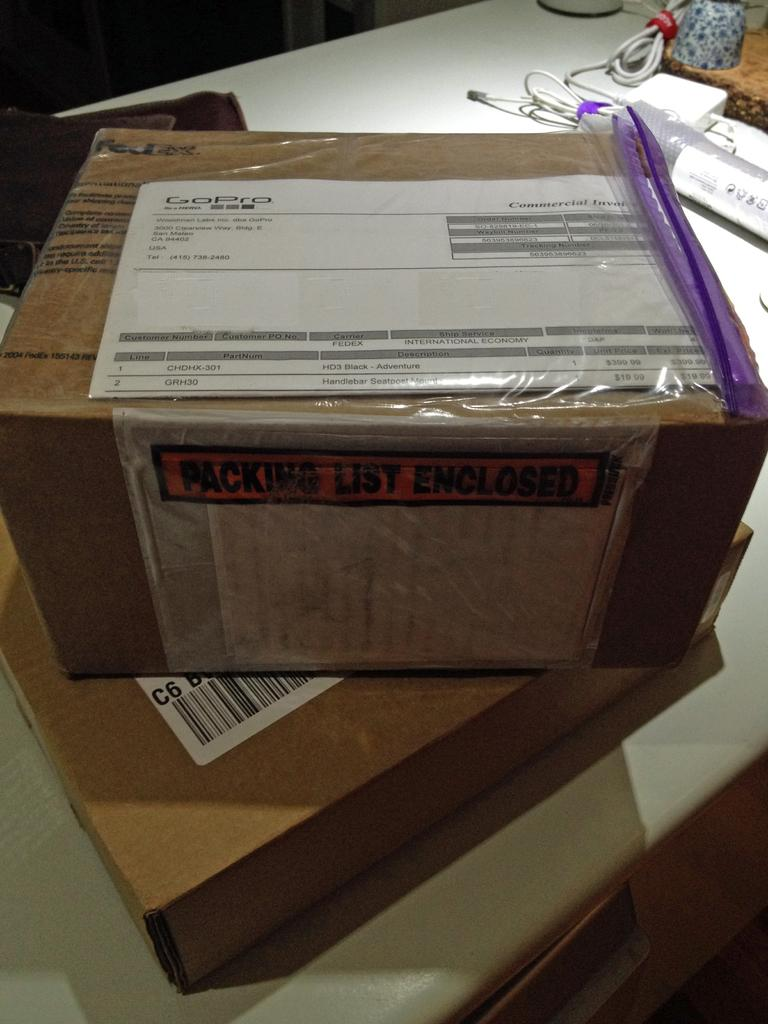<image>
Render a clear and concise summary of the photo. A box that says Packing List Enclosed on the front. 